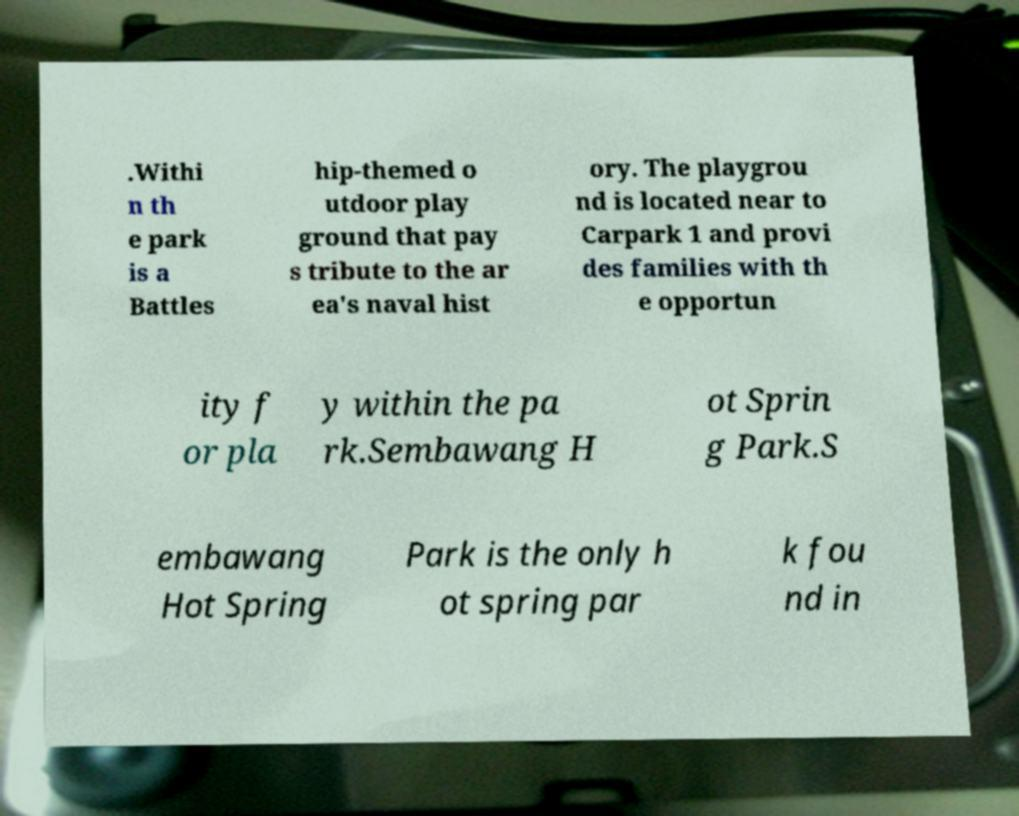Could you extract and type out the text from this image? .Withi n th e park is a Battles hip-themed o utdoor play ground that pay s tribute to the ar ea's naval hist ory. The playgrou nd is located near to Carpark 1 and provi des families with th e opportun ity f or pla y within the pa rk.Sembawang H ot Sprin g Park.S embawang Hot Spring Park is the only h ot spring par k fou nd in 